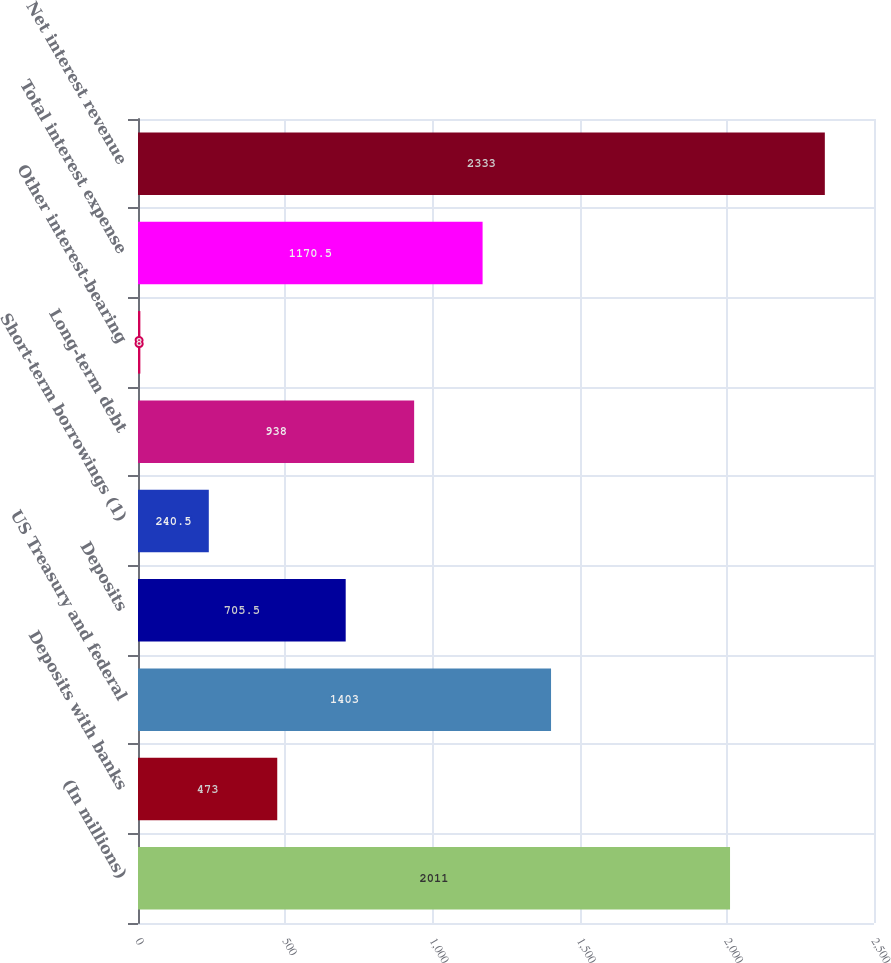Convert chart. <chart><loc_0><loc_0><loc_500><loc_500><bar_chart><fcel>(In millions)<fcel>Deposits with banks<fcel>US Treasury and federal<fcel>Deposits<fcel>Short-term borrowings (1)<fcel>Long-term debt<fcel>Other interest-bearing<fcel>Total interest expense<fcel>Net interest revenue<nl><fcel>2011<fcel>473<fcel>1403<fcel>705.5<fcel>240.5<fcel>938<fcel>8<fcel>1170.5<fcel>2333<nl></chart> 